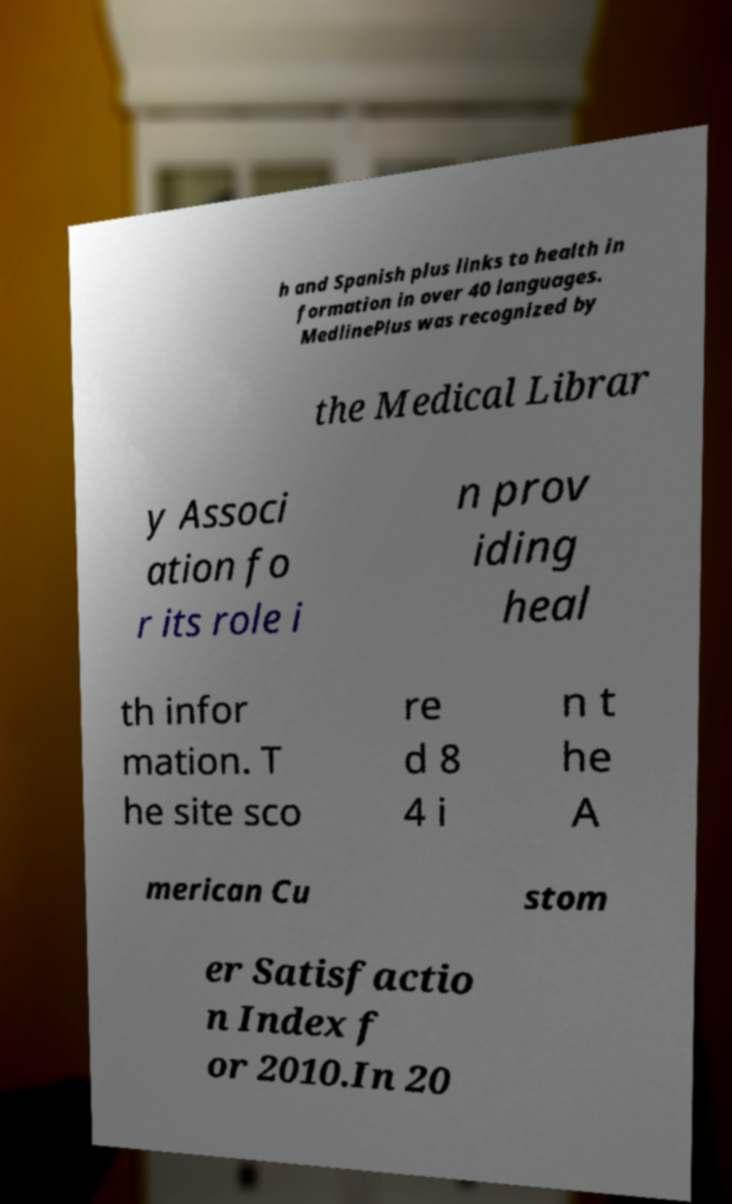For documentation purposes, I need the text within this image transcribed. Could you provide that? h and Spanish plus links to health in formation in over 40 languages. MedlinePlus was recognized by the Medical Librar y Associ ation fo r its role i n prov iding heal th infor mation. T he site sco re d 8 4 i n t he A merican Cu stom er Satisfactio n Index f or 2010.In 20 